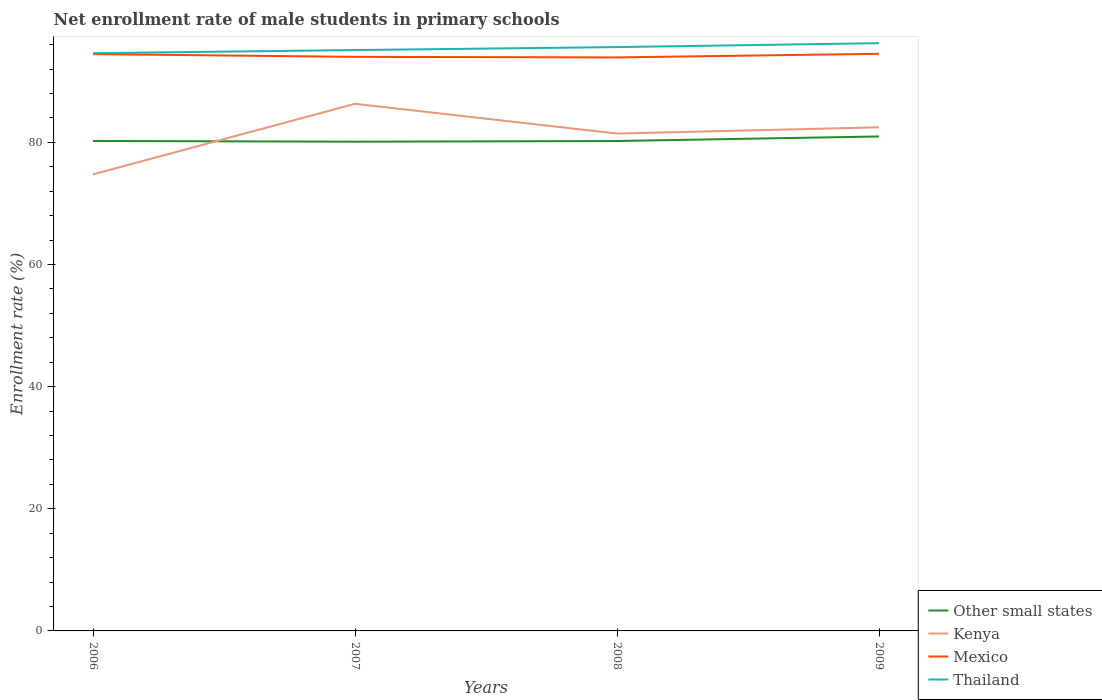How many different coloured lines are there?
Provide a succinct answer. 4. Is the number of lines equal to the number of legend labels?
Keep it short and to the point. Yes. Across all years, what is the maximum net enrollment rate of male students in primary schools in Other small states?
Provide a succinct answer. 80.11. In which year was the net enrollment rate of male students in primary schools in Mexico maximum?
Your answer should be very brief. 2008. What is the total net enrollment rate of male students in primary schools in Mexico in the graph?
Offer a very short reply. 0.45. What is the difference between the highest and the second highest net enrollment rate of male students in primary schools in Other small states?
Offer a terse response. 0.86. Is the net enrollment rate of male students in primary schools in Mexico strictly greater than the net enrollment rate of male students in primary schools in Other small states over the years?
Keep it short and to the point. No. How many lines are there?
Keep it short and to the point. 4. How many years are there in the graph?
Provide a short and direct response. 4. What is the difference between two consecutive major ticks on the Y-axis?
Give a very brief answer. 20. Are the values on the major ticks of Y-axis written in scientific E-notation?
Your answer should be compact. No. What is the title of the graph?
Make the answer very short. Net enrollment rate of male students in primary schools. Does "Ethiopia" appear as one of the legend labels in the graph?
Your answer should be very brief. No. What is the label or title of the X-axis?
Your response must be concise. Years. What is the label or title of the Y-axis?
Provide a succinct answer. Enrollment rate (%). What is the Enrollment rate (%) in Other small states in 2006?
Offer a terse response. 80.23. What is the Enrollment rate (%) of Kenya in 2006?
Make the answer very short. 74.76. What is the Enrollment rate (%) in Mexico in 2006?
Provide a succinct answer. 94.45. What is the Enrollment rate (%) of Thailand in 2006?
Your answer should be compact. 94.6. What is the Enrollment rate (%) in Other small states in 2007?
Make the answer very short. 80.11. What is the Enrollment rate (%) in Kenya in 2007?
Provide a short and direct response. 86.31. What is the Enrollment rate (%) of Mexico in 2007?
Offer a very short reply. 94. What is the Enrollment rate (%) in Thailand in 2007?
Keep it short and to the point. 95.11. What is the Enrollment rate (%) of Other small states in 2008?
Offer a terse response. 80.22. What is the Enrollment rate (%) in Kenya in 2008?
Provide a succinct answer. 81.44. What is the Enrollment rate (%) in Mexico in 2008?
Provide a succinct answer. 93.91. What is the Enrollment rate (%) in Thailand in 2008?
Provide a succinct answer. 95.6. What is the Enrollment rate (%) of Other small states in 2009?
Your answer should be very brief. 80.97. What is the Enrollment rate (%) in Kenya in 2009?
Offer a terse response. 82.46. What is the Enrollment rate (%) of Mexico in 2009?
Your answer should be compact. 94.5. What is the Enrollment rate (%) in Thailand in 2009?
Provide a short and direct response. 96.25. Across all years, what is the maximum Enrollment rate (%) of Other small states?
Ensure brevity in your answer.  80.97. Across all years, what is the maximum Enrollment rate (%) in Kenya?
Provide a short and direct response. 86.31. Across all years, what is the maximum Enrollment rate (%) of Mexico?
Offer a very short reply. 94.5. Across all years, what is the maximum Enrollment rate (%) of Thailand?
Ensure brevity in your answer.  96.25. Across all years, what is the minimum Enrollment rate (%) in Other small states?
Provide a succinct answer. 80.11. Across all years, what is the minimum Enrollment rate (%) in Kenya?
Ensure brevity in your answer.  74.76. Across all years, what is the minimum Enrollment rate (%) in Mexico?
Your answer should be very brief. 93.91. Across all years, what is the minimum Enrollment rate (%) in Thailand?
Your response must be concise. 94.6. What is the total Enrollment rate (%) in Other small states in the graph?
Your answer should be very brief. 321.52. What is the total Enrollment rate (%) in Kenya in the graph?
Provide a short and direct response. 324.97. What is the total Enrollment rate (%) of Mexico in the graph?
Give a very brief answer. 376.86. What is the total Enrollment rate (%) in Thailand in the graph?
Ensure brevity in your answer.  381.56. What is the difference between the Enrollment rate (%) in Other small states in 2006 and that in 2007?
Your answer should be compact. 0.12. What is the difference between the Enrollment rate (%) in Kenya in 2006 and that in 2007?
Your answer should be very brief. -11.55. What is the difference between the Enrollment rate (%) of Mexico in 2006 and that in 2007?
Keep it short and to the point. 0.45. What is the difference between the Enrollment rate (%) of Thailand in 2006 and that in 2007?
Give a very brief answer. -0.51. What is the difference between the Enrollment rate (%) in Other small states in 2006 and that in 2008?
Keep it short and to the point. 0.01. What is the difference between the Enrollment rate (%) in Kenya in 2006 and that in 2008?
Your answer should be compact. -6.68. What is the difference between the Enrollment rate (%) of Mexico in 2006 and that in 2008?
Your answer should be compact. 0.54. What is the difference between the Enrollment rate (%) in Thailand in 2006 and that in 2008?
Ensure brevity in your answer.  -1. What is the difference between the Enrollment rate (%) of Other small states in 2006 and that in 2009?
Your answer should be very brief. -0.73. What is the difference between the Enrollment rate (%) in Kenya in 2006 and that in 2009?
Provide a succinct answer. -7.71. What is the difference between the Enrollment rate (%) in Mexico in 2006 and that in 2009?
Your answer should be compact. -0.05. What is the difference between the Enrollment rate (%) of Thailand in 2006 and that in 2009?
Keep it short and to the point. -1.65. What is the difference between the Enrollment rate (%) in Other small states in 2007 and that in 2008?
Keep it short and to the point. -0.11. What is the difference between the Enrollment rate (%) of Kenya in 2007 and that in 2008?
Offer a very short reply. 4.87. What is the difference between the Enrollment rate (%) in Mexico in 2007 and that in 2008?
Your response must be concise. 0.09. What is the difference between the Enrollment rate (%) of Thailand in 2007 and that in 2008?
Provide a short and direct response. -0.49. What is the difference between the Enrollment rate (%) of Other small states in 2007 and that in 2009?
Your answer should be very brief. -0.86. What is the difference between the Enrollment rate (%) of Kenya in 2007 and that in 2009?
Ensure brevity in your answer.  3.85. What is the difference between the Enrollment rate (%) in Mexico in 2007 and that in 2009?
Provide a succinct answer. -0.5. What is the difference between the Enrollment rate (%) in Thailand in 2007 and that in 2009?
Provide a succinct answer. -1.13. What is the difference between the Enrollment rate (%) of Other small states in 2008 and that in 2009?
Offer a terse response. -0.75. What is the difference between the Enrollment rate (%) in Kenya in 2008 and that in 2009?
Offer a very short reply. -1.02. What is the difference between the Enrollment rate (%) of Mexico in 2008 and that in 2009?
Ensure brevity in your answer.  -0.59. What is the difference between the Enrollment rate (%) in Thailand in 2008 and that in 2009?
Give a very brief answer. -0.65. What is the difference between the Enrollment rate (%) in Other small states in 2006 and the Enrollment rate (%) in Kenya in 2007?
Provide a short and direct response. -6.08. What is the difference between the Enrollment rate (%) of Other small states in 2006 and the Enrollment rate (%) of Mexico in 2007?
Your response must be concise. -13.77. What is the difference between the Enrollment rate (%) of Other small states in 2006 and the Enrollment rate (%) of Thailand in 2007?
Make the answer very short. -14.88. What is the difference between the Enrollment rate (%) in Kenya in 2006 and the Enrollment rate (%) in Mexico in 2007?
Ensure brevity in your answer.  -19.24. What is the difference between the Enrollment rate (%) in Kenya in 2006 and the Enrollment rate (%) in Thailand in 2007?
Offer a very short reply. -20.35. What is the difference between the Enrollment rate (%) of Mexico in 2006 and the Enrollment rate (%) of Thailand in 2007?
Your answer should be very brief. -0.66. What is the difference between the Enrollment rate (%) of Other small states in 2006 and the Enrollment rate (%) of Kenya in 2008?
Your response must be concise. -1.21. What is the difference between the Enrollment rate (%) of Other small states in 2006 and the Enrollment rate (%) of Mexico in 2008?
Ensure brevity in your answer.  -13.68. What is the difference between the Enrollment rate (%) of Other small states in 2006 and the Enrollment rate (%) of Thailand in 2008?
Your answer should be very brief. -15.37. What is the difference between the Enrollment rate (%) of Kenya in 2006 and the Enrollment rate (%) of Mexico in 2008?
Provide a short and direct response. -19.15. What is the difference between the Enrollment rate (%) in Kenya in 2006 and the Enrollment rate (%) in Thailand in 2008?
Make the answer very short. -20.84. What is the difference between the Enrollment rate (%) of Mexico in 2006 and the Enrollment rate (%) of Thailand in 2008?
Your answer should be very brief. -1.15. What is the difference between the Enrollment rate (%) in Other small states in 2006 and the Enrollment rate (%) in Kenya in 2009?
Make the answer very short. -2.23. What is the difference between the Enrollment rate (%) in Other small states in 2006 and the Enrollment rate (%) in Mexico in 2009?
Your response must be concise. -14.27. What is the difference between the Enrollment rate (%) of Other small states in 2006 and the Enrollment rate (%) of Thailand in 2009?
Offer a terse response. -16.02. What is the difference between the Enrollment rate (%) in Kenya in 2006 and the Enrollment rate (%) in Mexico in 2009?
Your response must be concise. -19.74. What is the difference between the Enrollment rate (%) in Kenya in 2006 and the Enrollment rate (%) in Thailand in 2009?
Offer a terse response. -21.49. What is the difference between the Enrollment rate (%) of Mexico in 2006 and the Enrollment rate (%) of Thailand in 2009?
Offer a terse response. -1.79. What is the difference between the Enrollment rate (%) of Other small states in 2007 and the Enrollment rate (%) of Kenya in 2008?
Offer a very short reply. -1.33. What is the difference between the Enrollment rate (%) of Other small states in 2007 and the Enrollment rate (%) of Mexico in 2008?
Make the answer very short. -13.8. What is the difference between the Enrollment rate (%) of Other small states in 2007 and the Enrollment rate (%) of Thailand in 2008?
Your answer should be very brief. -15.49. What is the difference between the Enrollment rate (%) of Kenya in 2007 and the Enrollment rate (%) of Mexico in 2008?
Provide a succinct answer. -7.6. What is the difference between the Enrollment rate (%) of Kenya in 2007 and the Enrollment rate (%) of Thailand in 2008?
Your answer should be very brief. -9.29. What is the difference between the Enrollment rate (%) of Mexico in 2007 and the Enrollment rate (%) of Thailand in 2008?
Provide a short and direct response. -1.6. What is the difference between the Enrollment rate (%) of Other small states in 2007 and the Enrollment rate (%) of Kenya in 2009?
Provide a succinct answer. -2.35. What is the difference between the Enrollment rate (%) of Other small states in 2007 and the Enrollment rate (%) of Mexico in 2009?
Your response must be concise. -14.39. What is the difference between the Enrollment rate (%) of Other small states in 2007 and the Enrollment rate (%) of Thailand in 2009?
Ensure brevity in your answer.  -16.14. What is the difference between the Enrollment rate (%) of Kenya in 2007 and the Enrollment rate (%) of Mexico in 2009?
Your response must be concise. -8.19. What is the difference between the Enrollment rate (%) of Kenya in 2007 and the Enrollment rate (%) of Thailand in 2009?
Provide a succinct answer. -9.93. What is the difference between the Enrollment rate (%) in Mexico in 2007 and the Enrollment rate (%) in Thailand in 2009?
Your response must be concise. -2.25. What is the difference between the Enrollment rate (%) in Other small states in 2008 and the Enrollment rate (%) in Kenya in 2009?
Provide a succinct answer. -2.25. What is the difference between the Enrollment rate (%) of Other small states in 2008 and the Enrollment rate (%) of Mexico in 2009?
Make the answer very short. -14.28. What is the difference between the Enrollment rate (%) in Other small states in 2008 and the Enrollment rate (%) in Thailand in 2009?
Offer a terse response. -16.03. What is the difference between the Enrollment rate (%) of Kenya in 2008 and the Enrollment rate (%) of Mexico in 2009?
Offer a terse response. -13.06. What is the difference between the Enrollment rate (%) of Kenya in 2008 and the Enrollment rate (%) of Thailand in 2009?
Your response must be concise. -14.81. What is the difference between the Enrollment rate (%) in Mexico in 2008 and the Enrollment rate (%) in Thailand in 2009?
Ensure brevity in your answer.  -2.34. What is the average Enrollment rate (%) in Other small states per year?
Ensure brevity in your answer.  80.38. What is the average Enrollment rate (%) in Kenya per year?
Your answer should be compact. 81.24. What is the average Enrollment rate (%) of Mexico per year?
Your answer should be compact. 94.22. What is the average Enrollment rate (%) of Thailand per year?
Offer a very short reply. 95.39. In the year 2006, what is the difference between the Enrollment rate (%) in Other small states and Enrollment rate (%) in Kenya?
Give a very brief answer. 5.47. In the year 2006, what is the difference between the Enrollment rate (%) of Other small states and Enrollment rate (%) of Mexico?
Your answer should be very brief. -14.22. In the year 2006, what is the difference between the Enrollment rate (%) in Other small states and Enrollment rate (%) in Thailand?
Your answer should be compact. -14.37. In the year 2006, what is the difference between the Enrollment rate (%) of Kenya and Enrollment rate (%) of Mexico?
Offer a very short reply. -19.69. In the year 2006, what is the difference between the Enrollment rate (%) in Kenya and Enrollment rate (%) in Thailand?
Your response must be concise. -19.84. In the year 2006, what is the difference between the Enrollment rate (%) in Mexico and Enrollment rate (%) in Thailand?
Offer a terse response. -0.15. In the year 2007, what is the difference between the Enrollment rate (%) of Other small states and Enrollment rate (%) of Kenya?
Give a very brief answer. -6.2. In the year 2007, what is the difference between the Enrollment rate (%) of Other small states and Enrollment rate (%) of Mexico?
Keep it short and to the point. -13.89. In the year 2007, what is the difference between the Enrollment rate (%) of Other small states and Enrollment rate (%) of Thailand?
Keep it short and to the point. -15. In the year 2007, what is the difference between the Enrollment rate (%) of Kenya and Enrollment rate (%) of Mexico?
Provide a short and direct response. -7.69. In the year 2007, what is the difference between the Enrollment rate (%) of Kenya and Enrollment rate (%) of Thailand?
Make the answer very short. -8.8. In the year 2007, what is the difference between the Enrollment rate (%) of Mexico and Enrollment rate (%) of Thailand?
Offer a very short reply. -1.11. In the year 2008, what is the difference between the Enrollment rate (%) in Other small states and Enrollment rate (%) in Kenya?
Offer a terse response. -1.22. In the year 2008, what is the difference between the Enrollment rate (%) of Other small states and Enrollment rate (%) of Mexico?
Provide a short and direct response. -13.69. In the year 2008, what is the difference between the Enrollment rate (%) in Other small states and Enrollment rate (%) in Thailand?
Offer a terse response. -15.38. In the year 2008, what is the difference between the Enrollment rate (%) in Kenya and Enrollment rate (%) in Mexico?
Provide a short and direct response. -12.47. In the year 2008, what is the difference between the Enrollment rate (%) in Kenya and Enrollment rate (%) in Thailand?
Your answer should be compact. -14.16. In the year 2008, what is the difference between the Enrollment rate (%) of Mexico and Enrollment rate (%) of Thailand?
Offer a terse response. -1.69. In the year 2009, what is the difference between the Enrollment rate (%) in Other small states and Enrollment rate (%) in Kenya?
Provide a succinct answer. -1.5. In the year 2009, what is the difference between the Enrollment rate (%) of Other small states and Enrollment rate (%) of Mexico?
Ensure brevity in your answer.  -13.53. In the year 2009, what is the difference between the Enrollment rate (%) of Other small states and Enrollment rate (%) of Thailand?
Offer a very short reply. -15.28. In the year 2009, what is the difference between the Enrollment rate (%) of Kenya and Enrollment rate (%) of Mexico?
Make the answer very short. -12.04. In the year 2009, what is the difference between the Enrollment rate (%) in Kenya and Enrollment rate (%) in Thailand?
Offer a very short reply. -13.78. In the year 2009, what is the difference between the Enrollment rate (%) in Mexico and Enrollment rate (%) in Thailand?
Make the answer very short. -1.75. What is the ratio of the Enrollment rate (%) in Kenya in 2006 to that in 2007?
Keep it short and to the point. 0.87. What is the ratio of the Enrollment rate (%) in Thailand in 2006 to that in 2007?
Your answer should be compact. 0.99. What is the ratio of the Enrollment rate (%) of Kenya in 2006 to that in 2008?
Your answer should be compact. 0.92. What is the ratio of the Enrollment rate (%) in Mexico in 2006 to that in 2008?
Your answer should be very brief. 1.01. What is the ratio of the Enrollment rate (%) of Thailand in 2006 to that in 2008?
Keep it short and to the point. 0.99. What is the ratio of the Enrollment rate (%) in Other small states in 2006 to that in 2009?
Ensure brevity in your answer.  0.99. What is the ratio of the Enrollment rate (%) in Kenya in 2006 to that in 2009?
Provide a short and direct response. 0.91. What is the ratio of the Enrollment rate (%) of Thailand in 2006 to that in 2009?
Offer a very short reply. 0.98. What is the ratio of the Enrollment rate (%) of Other small states in 2007 to that in 2008?
Your answer should be compact. 1. What is the ratio of the Enrollment rate (%) in Kenya in 2007 to that in 2008?
Make the answer very short. 1.06. What is the ratio of the Enrollment rate (%) of Mexico in 2007 to that in 2008?
Your answer should be compact. 1. What is the ratio of the Enrollment rate (%) of Other small states in 2007 to that in 2009?
Make the answer very short. 0.99. What is the ratio of the Enrollment rate (%) in Kenya in 2007 to that in 2009?
Offer a very short reply. 1.05. What is the ratio of the Enrollment rate (%) of Mexico in 2007 to that in 2009?
Your response must be concise. 0.99. What is the ratio of the Enrollment rate (%) in Other small states in 2008 to that in 2009?
Provide a short and direct response. 0.99. What is the ratio of the Enrollment rate (%) of Kenya in 2008 to that in 2009?
Your answer should be very brief. 0.99. What is the ratio of the Enrollment rate (%) of Mexico in 2008 to that in 2009?
Provide a short and direct response. 0.99. What is the difference between the highest and the second highest Enrollment rate (%) in Other small states?
Your answer should be very brief. 0.73. What is the difference between the highest and the second highest Enrollment rate (%) in Kenya?
Make the answer very short. 3.85. What is the difference between the highest and the second highest Enrollment rate (%) in Mexico?
Offer a very short reply. 0.05. What is the difference between the highest and the second highest Enrollment rate (%) of Thailand?
Your response must be concise. 0.65. What is the difference between the highest and the lowest Enrollment rate (%) of Other small states?
Offer a very short reply. 0.86. What is the difference between the highest and the lowest Enrollment rate (%) in Kenya?
Provide a succinct answer. 11.55. What is the difference between the highest and the lowest Enrollment rate (%) in Mexico?
Your answer should be compact. 0.59. What is the difference between the highest and the lowest Enrollment rate (%) of Thailand?
Your answer should be compact. 1.65. 